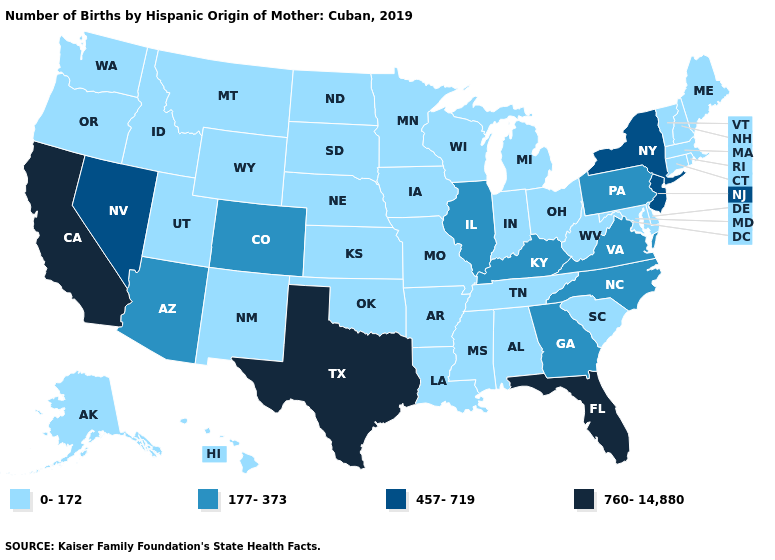Which states have the lowest value in the MidWest?
Concise answer only. Indiana, Iowa, Kansas, Michigan, Minnesota, Missouri, Nebraska, North Dakota, Ohio, South Dakota, Wisconsin. Among the states that border Maine , which have the highest value?
Answer briefly. New Hampshire. Does the map have missing data?
Quick response, please. No. What is the value of Iowa?
Give a very brief answer. 0-172. What is the value of Arizona?
Be succinct. 177-373. Among the states that border Massachusetts , which have the highest value?
Give a very brief answer. New York. What is the lowest value in the West?
Concise answer only. 0-172. How many symbols are there in the legend?
Answer briefly. 4. Does Illinois have the highest value in the MidWest?
Give a very brief answer. Yes. What is the value of Washington?
Keep it brief. 0-172. Which states have the lowest value in the USA?
Short answer required. Alabama, Alaska, Arkansas, Connecticut, Delaware, Hawaii, Idaho, Indiana, Iowa, Kansas, Louisiana, Maine, Maryland, Massachusetts, Michigan, Minnesota, Mississippi, Missouri, Montana, Nebraska, New Hampshire, New Mexico, North Dakota, Ohio, Oklahoma, Oregon, Rhode Island, South Carolina, South Dakota, Tennessee, Utah, Vermont, Washington, West Virginia, Wisconsin, Wyoming. Which states have the highest value in the USA?
Give a very brief answer. California, Florida, Texas. What is the lowest value in the South?
Quick response, please. 0-172. Is the legend a continuous bar?
Answer briefly. No. What is the highest value in the USA?
Keep it brief. 760-14,880. 